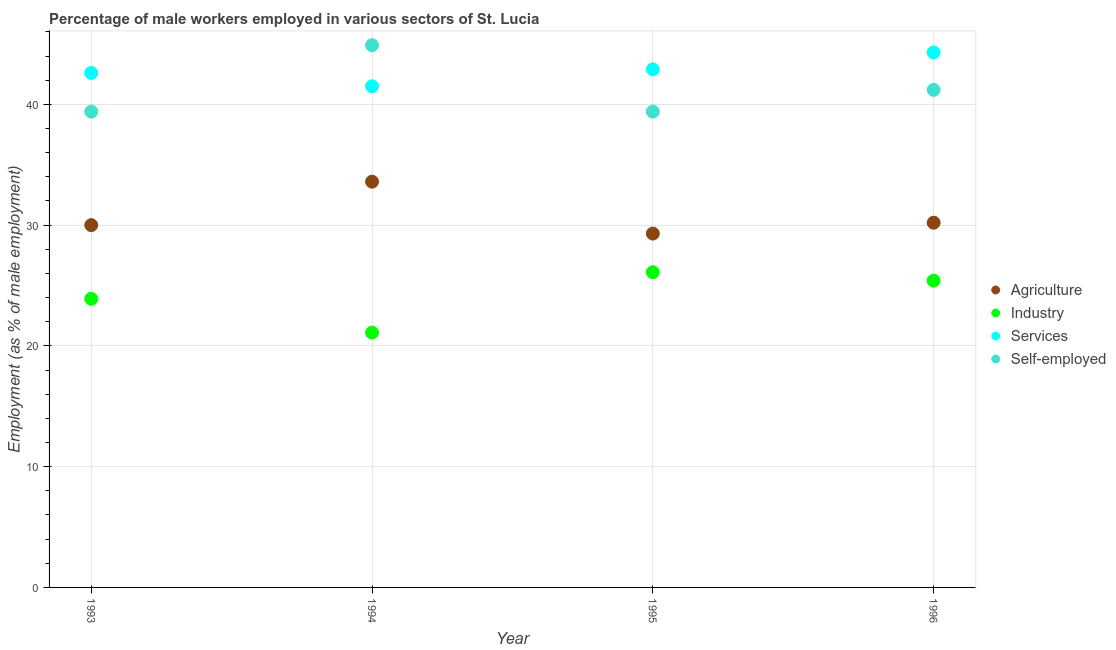How many different coloured dotlines are there?
Provide a succinct answer. 4. What is the percentage of male workers in industry in 1993?
Keep it short and to the point. 23.9. Across all years, what is the maximum percentage of male workers in agriculture?
Provide a short and direct response. 33.6. Across all years, what is the minimum percentage of male workers in agriculture?
Your answer should be compact. 29.3. In which year was the percentage of male workers in services maximum?
Ensure brevity in your answer.  1996. What is the total percentage of male workers in agriculture in the graph?
Make the answer very short. 123.1. What is the difference between the percentage of self employed male workers in 1995 and that in 1996?
Your answer should be very brief. -1.8. What is the difference between the percentage of male workers in services in 1994 and the percentage of self employed male workers in 1996?
Offer a terse response. 0.3. What is the average percentage of male workers in agriculture per year?
Ensure brevity in your answer.  30.77. In the year 1993, what is the difference between the percentage of self employed male workers and percentage of male workers in industry?
Give a very brief answer. 15.5. What is the ratio of the percentage of self employed male workers in 1993 to that in 1995?
Provide a succinct answer. 1. Is the percentage of male workers in services in 1993 less than that in 1996?
Your answer should be very brief. Yes. Is the difference between the percentage of male workers in industry in 1993 and 1995 greater than the difference between the percentage of male workers in agriculture in 1993 and 1995?
Offer a very short reply. No. What is the difference between the highest and the second highest percentage of male workers in agriculture?
Your answer should be compact. 3.4. What is the difference between the highest and the lowest percentage of male workers in services?
Provide a short and direct response. 2.8. In how many years, is the percentage of male workers in services greater than the average percentage of male workers in services taken over all years?
Provide a short and direct response. 2. Is the sum of the percentage of male workers in services in 1995 and 1996 greater than the maximum percentage of male workers in agriculture across all years?
Your answer should be compact. Yes. Is the percentage of male workers in services strictly greater than the percentage of male workers in industry over the years?
Offer a terse response. Yes. Does the graph contain grids?
Ensure brevity in your answer.  Yes. How are the legend labels stacked?
Provide a short and direct response. Vertical. What is the title of the graph?
Offer a very short reply. Percentage of male workers employed in various sectors of St. Lucia. What is the label or title of the Y-axis?
Give a very brief answer. Employment (as % of male employment). What is the Employment (as % of male employment) of Agriculture in 1993?
Offer a terse response. 30. What is the Employment (as % of male employment) of Industry in 1993?
Offer a terse response. 23.9. What is the Employment (as % of male employment) in Services in 1993?
Provide a short and direct response. 42.6. What is the Employment (as % of male employment) of Self-employed in 1993?
Your answer should be compact. 39.4. What is the Employment (as % of male employment) of Agriculture in 1994?
Your answer should be compact. 33.6. What is the Employment (as % of male employment) in Industry in 1994?
Give a very brief answer. 21.1. What is the Employment (as % of male employment) of Services in 1994?
Make the answer very short. 41.5. What is the Employment (as % of male employment) of Self-employed in 1994?
Your response must be concise. 44.9. What is the Employment (as % of male employment) of Agriculture in 1995?
Your answer should be very brief. 29.3. What is the Employment (as % of male employment) in Industry in 1995?
Make the answer very short. 26.1. What is the Employment (as % of male employment) of Services in 1995?
Offer a terse response. 42.9. What is the Employment (as % of male employment) of Self-employed in 1995?
Your response must be concise. 39.4. What is the Employment (as % of male employment) in Agriculture in 1996?
Keep it short and to the point. 30.2. What is the Employment (as % of male employment) in Industry in 1996?
Your answer should be very brief. 25.4. What is the Employment (as % of male employment) of Services in 1996?
Offer a very short reply. 44.3. What is the Employment (as % of male employment) of Self-employed in 1996?
Make the answer very short. 41.2. Across all years, what is the maximum Employment (as % of male employment) in Agriculture?
Ensure brevity in your answer.  33.6. Across all years, what is the maximum Employment (as % of male employment) in Industry?
Provide a short and direct response. 26.1. Across all years, what is the maximum Employment (as % of male employment) of Services?
Ensure brevity in your answer.  44.3. Across all years, what is the maximum Employment (as % of male employment) of Self-employed?
Provide a short and direct response. 44.9. Across all years, what is the minimum Employment (as % of male employment) in Agriculture?
Provide a succinct answer. 29.3. Across all years, what is the minimum Employment (as % of male employment) of Industry?
Your answer should be very brief. 21.1. Across all years, what is the minimum Employment (as % of male employment) in Services?
Your answer should be compact. 41.5. Across all years, what is the minimum Employment (as % of male employment) of Self-employed?
Give a very brief answer. 39.4. What is the total Employment (as % of male employment) of Agriculture in the graph?
Your answer should be compact. 123.1. What is the total Employment (as % of male employment) of Industry in the graph?
Give a very brief answer. 96.5. What is the total Employment (as % of male employment) in Services in the graph?
Your answer should be very brief. 171.3. What is the total Employment (as % of male employment) of Self-employed in the graph?
Your answer should be very brief. 164.9. What is the difference between the Employment (as % of male employment) in Agriculture in 1993 and that in 1994?
Offer a terse response. -3.6. What is the difference between the Employment (as % of male employment) in Industry in 1993 and that in 1994?
Ensure brevity in your answer.  2.8. What is the difference between the Employment (as % of male employment) of Services in 1993 and that in 1994?
Your response must be concise. 1.1. What is the difference between the Employment (as % of male employment) in Industry in 1993 and that in 1995?
Your answer should be compact. -2.2. What is the difference between the Employment (as % of male employment) in Agriculture in 1993 and that in 1996?
Your answer should be compact. -0.2. What is the difference between the Employment (as % of male employment) in Industry in 1993 and that in 1996?
Ensure brevity in your answer.  -1.5. What is the difference between the Employment (as % of male employment) in Industry in 1994 and that in 1995?
Make the answer very short. -5. What is the difference between the Employment (as % of male employment) of Self-employed in 1994 and that in 1995?
Offer a very short reply. 5.5. What is the difference between the Employment (as % of male employment) of Industry in 1994 and that in 1996?
Offer a very short reply. -4.3. What is the difference between the Employment (as % of male employment) in Services in 1994 and that in 1996?
Offer a terse response. -2.8. What is the difference between the Employment (as % of male employment) of Self-employed in 1994 and that in 1996?
Your response must be concise. 3.7. What is the difference between the Employment (as % of male employment) in Agriculture in 1995 and that in 1996?
Provide a short and direct response. -0.9. What is the difference between the Employment (as % of male employment) of Services in 1995 and that in 1996?
Your answer should be compact. -1.4. What is the difference between the Employment (as % of male employment) of Self-employed in 1995 and that in 1996?
Give a very brief answer. -1.8. What is the difference between the Employment (as % of male employment) of Agriculture in 1993 and the Employment (as % of male employment) of Self-employed in 1994?
Offer a terse response. -14.9. What is the difference between the Employment (as % of male employment) in Industry in 1993 and the Employment (as % of male employment) in Services in 1994?
Your response must be concise. -17.6. What is the difference between the Employment (as % of male employment) in Services in 1993 and the Employment (as % of male employment) in Self-employed in 1994?
Provide a succinct answer. -2.3. What is the difference between the Employment (as % of male employment) of Agriculture in 1993 and the Employment (as % of male employment) of Services in 1995?
Give a very brief answer. -12.9. What is the difference between the Employment (as % of male employment) in Agriculture in 1993 and the Employment (as % of male employment) in Self-employed in 1995?
Offer a very short reply. -9.4. What is the difference between the Employment (as % of male employment) in Industry in 1993 and the Employment (as % of male employment) in Services in 1995?
Provide a short and direct response. -19. What is the difference between the Employment (as % of male employment) in Industry in 1993 and the Employment (as % of male employment) in Self-employed in 1995?
Ensure brevity in your answer.  -15.5. What is the difference between the Employment (as % of male employment) of Agriculture in 1993 and the Employment (as % of male employment) of Industry in 1996?
Provide a short and direct response. 4.6. What is the difference between the Employment (as % of male employment) of Agriculture in 1993 and the Employment (as % of male employment) of Services in 1996?
Ensure brevity in your answer.  -14.3. What is the difference between the Employment (as % of male employment) in Agriculture in 1993 and the Employment (as % of male employment) in Self-employed in 1996?
Offer a terse response. -11.2. What is the difference between the Employment (as % of male employment) of Industry in 1993 and the Employment (as % of male employment) of Services in 1996?
Give a very brief answer. -20.4. What is the difference between the Employment (as % of male employment) in Industry in 1993 and the Employment (as % of male employment) in Self-employed in 1996?
Provide a short and direct response. -17.3. What is the difference between the Employment (as % of male employment) in Agriculture in 1994 and the Employment (as % of male employment) in Services in 1995?
Your answer should be very brief. -9.3. What is the difference between the Employment (as % of male employment) of Agriculture in 1994 and the Employment (as % of male employment) of Self-employed in 1995?
Your answer should be compact. -5.8. What is the difference between the Employment (as % of male employment) of Industry in 1994 and the Employment (as % of male employment) of Services in 1995?
Keep it short and to the point. -21.8. What is the difference between the Employment (as % of male employment) of Industry in 1994 and the Employment (as % of male employment) of Self-employed in 1995?
Provide a succinct answer. -18.3. What is the difference between the Employment (as % of male employment) of Agriculture in 1994 and the Employment (as % of male employment) of Services in 1996?
Ensure brevity in your answer.  -10.7. What is the difference between the Employment (as % of male employment) in Industry in 1994 and the Employment (as % of male employment) in Services in 1996?
Offer a terse response. -23.2. What is the difference between the Employment (as % of male employment) of Industry in 1994 and the Employment (as % of male employment) of Self-employed in 1996?
Give a very brief answer. -20.1. What is the difference between the Employment (as % of male employment) of Services in 1994 and the Employment (as % of male employment) of Self-employed in 1996?
Your answer should be very brief. 0.3. What is the difference between the Employment (as % of male employment) of Agriculture in 1995 and the Employment (as % of male employment) of Self-employed in 1996?
Keep it short and to the point. -11.9. What is the difference between the Employment (as % of male employment) in Industry in 1995 and the Employment (as % of male employment) in Services in 1996?
Provide a succinct answer. -18.2. What is the difference between the Employment (as % of male employment) of Industry in 1995 and the Employment (as % of male employment) of Self-employed in 1996?
Provide a succinct answer. -15.1. What is the average Employment (as % of male employment) in Agriculture per year?
Offer a very short reply. 30.77. What is the average Employment (as % of male employment) in Industry per year?
Make the answer very short. 24.12. What is the average Employment (as % of male employment) in Services per year?
Your response must be concise. 42.83. What is the average Employment (as % of male employment) of Self-employed per year?
Your answer should be compact. 41.23. In the year 1993, what is the difference between the Employment (as % of male employment) of Agriculture and Employment (as % of male employment) of Services?
Your answer should be very brief. -12.6. In the year 1993, what is the difference between the Employment (as % of male employment) in Agriculture and Employment (as % of male employment) in Self-employed?
Your response must be concise. -9.4. In the year 1993, what is the difference between the Employment (as % of male employment) in Industry and Employment (as % of male employment) in Services?
Your answer should be compact. -18.7. In the year 1993, what is the difference between the Employment (as % of male employment) of Industry and Employment (as % of male employment) of Self-employed?
Make the answer very short. -15.5. In the year 1994, what is the difference between the Employment (as % of male employment) in Agriculture and Employment (as % of male employment) in Industry?
Offer a very short reply. 12.5. In the year 1994, what is the difference between the Employment (as % of male employment) of Agriculture and Employment (as % of male employment) of Services?
Provide a succinct answer. -7.9. In the year 1994, what is the difference between the Employment (as % of male employment) of Industry and Employment (as % of male employment) of Services?
Provide a succinct answer. -20.4. In the year 1994, what is the difference between the Employment (as % of male employment) in Industry and Employment (as % of male employment) in Self-employed?
Give a very brief answer. -23.8. In the year 1995, what is the difference between the Employment (as % of male employment) of Industry and Employment (as % of male employment) of Services?
Offer a very short reply. -16.8. In the year 1996, what is the difference between the Employment (as % of male employment) of Agriculture and Employment (as % of male employment) of Services?
Your answer should be compact. -14.1. In the year 1996, what is the difference between the Employment (as % of male employment) in Industry and Employment (as % of male employment) in Services?
Offer a very short reply. -18.9. In the year 1996, what is the difference between the Employment (as % of male employment) in Industry and Employment (as % of male employment) in Self-employed?
Make the answer very short. -15.8. What is the ratio of the Employment (as % of male employment) in Agriculture in 1993 to that in 1994?
Make the answer very short. 0.89. What is the ratio of the Employment (as % of male employment) of Industry in 1993 to that in 1994?
Your answer should be very brief. 1.13. What is the ratio of the Employment (as % of male employment) in Services in 1993 to that in 1994?
Keep it short and to the point. 1.03. What is the ratio of the Employment (as % of male employment) in Self-employed in 1993 to that in 1994?
Offer a terse response. 0.88. What is the ratio of the Employment (as % of male employment) in Agriculture in 1993 to that in 1995?
Give a very brief answer. 1.02. What is the ratio of the Employment (as % of male employment) of Industry in 1993 to that in 1995?
Your answer should be very brief. 0.92. What is the ratio of the Employment (as % of male employment) of Industry in 1993 to that in 1996?
Offer a terse response. 0.94. What is the ratio of the Employment (as % of male employment) in Services in 1993 to that in 1996?
Your response must be concise. 0.96. What is the ratio of the Employment (as % of male employment) of Self-employed in 1993 to that in 1996?
Your answer should be very brief. 0.96. What is the ratio of the Employment (as % of male employment) in Agriculture in 1994 to that in 1995?
Your answer should be compact. 1.15. What is the ratio of the Employment (as % of male employment) in Industry in 1994 to that in 1995?
Provide a short and direct response. 0.81. What is the ratio of the Employment (as % of male employment) of Services in 1994 to that in 1995?
Your answer should be compact. 0.97. What is the ratio of the Employment (as % of male employment) in Self-employed in 1994 to that in 1995?
Your answer should be very brief. 1.14. What is the ratio of the Employment (as % of male employment) of Agriculture in 1994 to that in 1996?
Give a very brief answer. 1.11. What is the ratio of the Employment (as % of male employment) in Industry in 1994 to that in 1996?
Keep it short and to the point. 0.83. What is the ratio of the Employment (as % of male employment) in Services in 1994 to that in 1996?
Provide a short and direct response. 0.94. What is the ratio of the Employment (as % of male employment) in Self-employed in 1994 to that in 1996?
Provide a succinct answer. 1.09. What is the ratio of the Employment (as % of male employment) in Agriculture in 1995 to that in 1996?
Offer a very short reply. 0.97. What is the ratio of the Employment (as % of male employment) in Industry in 1995 to that in 1996?
Make the answer very short. 1.03. What is the ratio of the Employment (as % of male employment) of Services in 1995 to that in 1996?
Give a very brief answer. 0.97. What is the ratio of the Employment (as % of male employment) of Self-employed in 1995 to that in 1996?
Offer a very short reply. 0.96. What is the difference between the highest and the second highest Employment (as % of male employment) in Agriculture?
Your response must be concise. 3.4. What is the difference between the highest and the second highest Employment (as % of male employment) in Services?
Provide a short and direct response. 1.4. What is the difference between the highest and the second highest Employment (as % of male employment) of Self-employed?
Give a very brief answer. 3.7. What is the difference between the highest and the lowest Employment (as % of male employment) of Services?
Give a very brief answer. 2.8. What is the difference between the highest and the lowest Employment (as % of male employment) of Self-employed?
Offer a terse response. 5.5. 